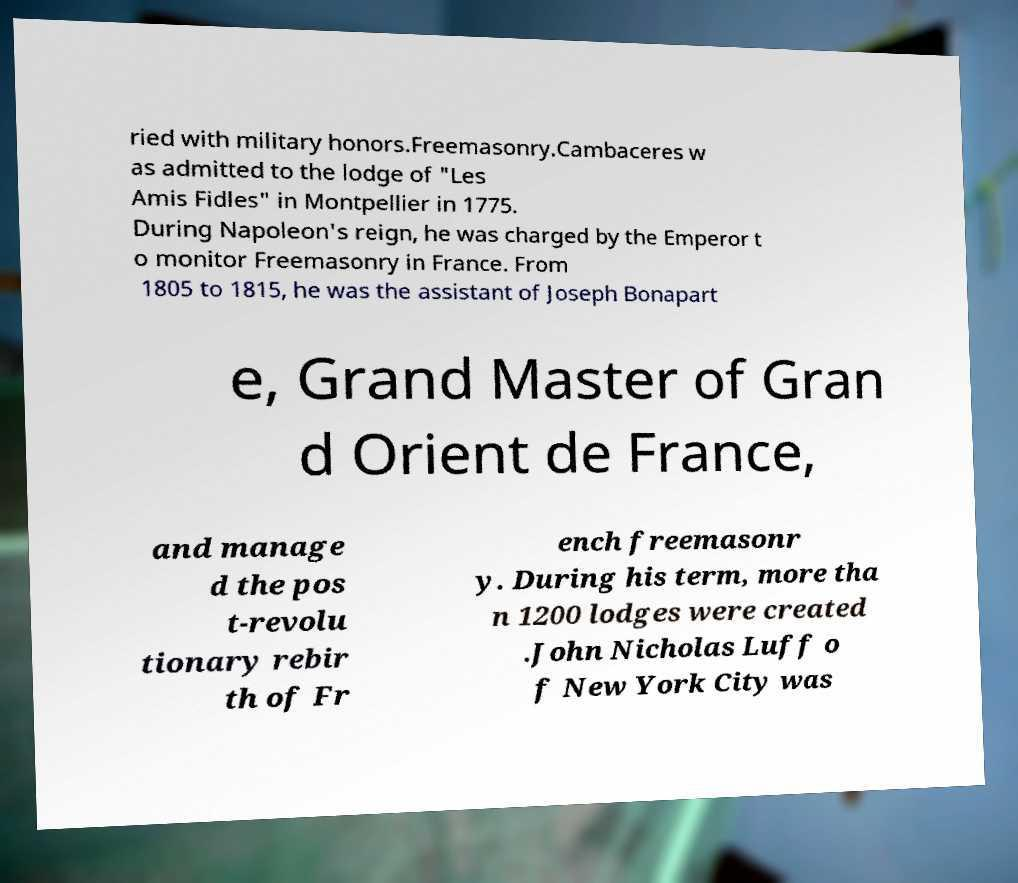Please identify and transcribe the text found in this image. ried with military honors.Freemasonry.Cambaceres w as admitted to the lodge of "Les Amis Fidles" in Montpellier in 1775. During Napoleon's reign, he was charged by the Emperor t o monitor Freemasonry in France. From 1805 to 1815, he was the assistant of Joseph Bonapart e, Grand Master of Gran d Orient de France, and manage d the pos t-revolu tionary rebir th of Fr ench freemasonr y. During his term, more tha n 1200 lodges were created .John Nicholas Luff o f New York City was 